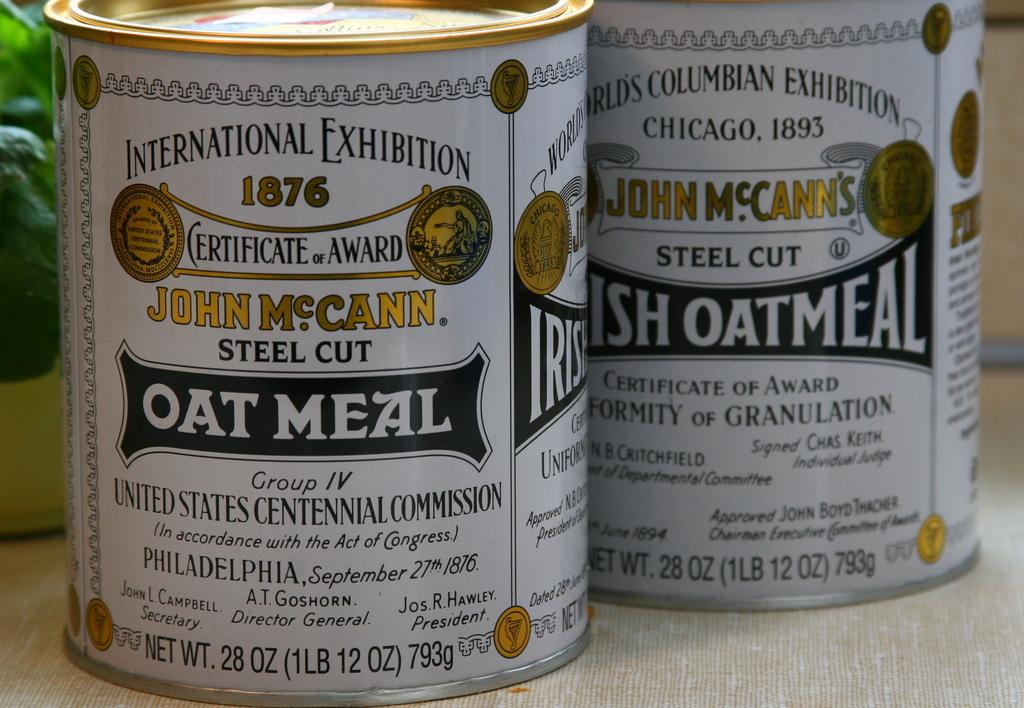<image>
Offer a succinct explanation of the picture presented. A can of steel cut oatmeal sits in front of some leaves 